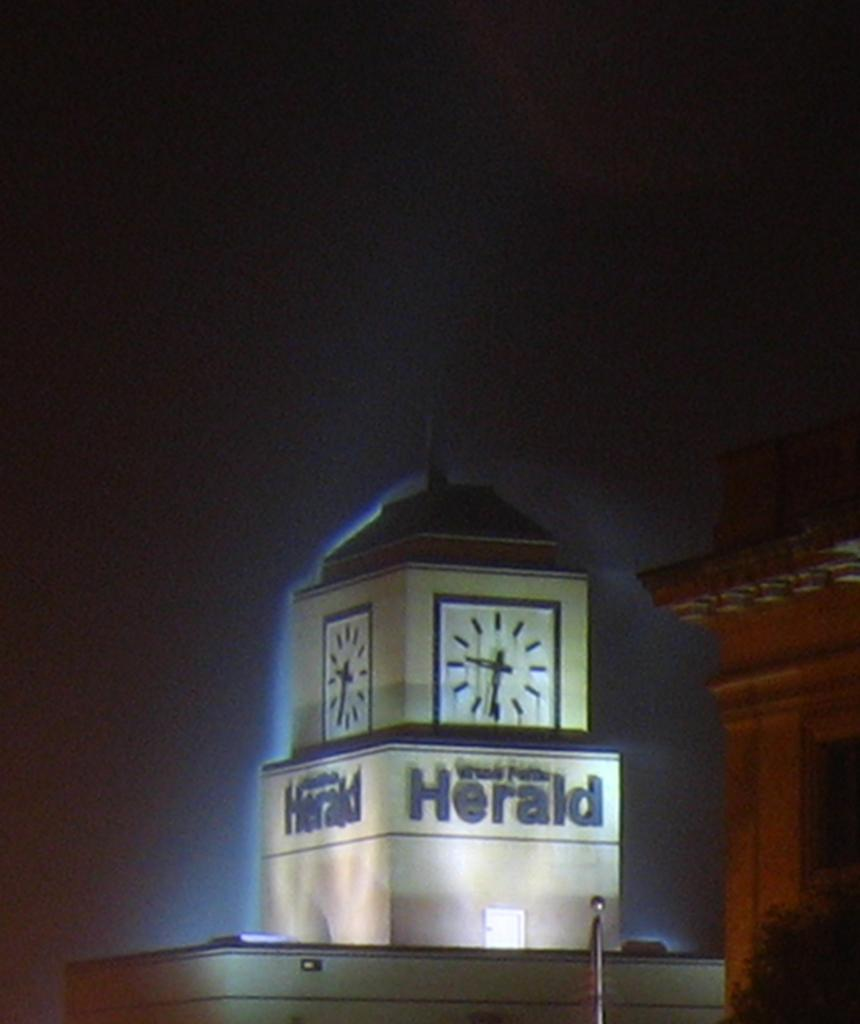<image>
Present a compact description of the photo's key features. A Herald clock tower is illuminated by blue lights. 